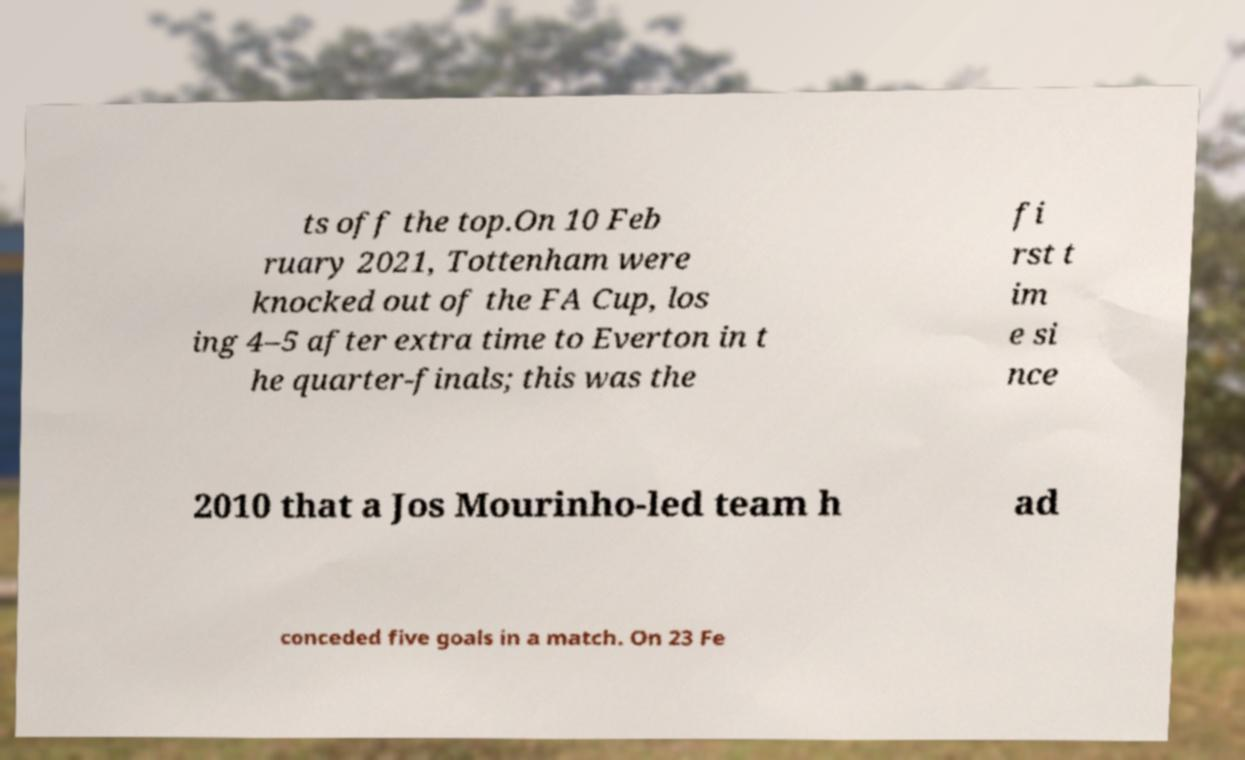Could you assist in decoding the text presented in this image and type it out clearly? ts off the top.On 10 Feb ruary 2021, Tottenham were knocked out of the FA Cup, los ing 4–5 after extra time to Everton in t he quarter-finals; this was the fi rst t im e si nce 2010 that a Jos Mourinho-led team h ad conceded five goals in a match. On 23 Fe 